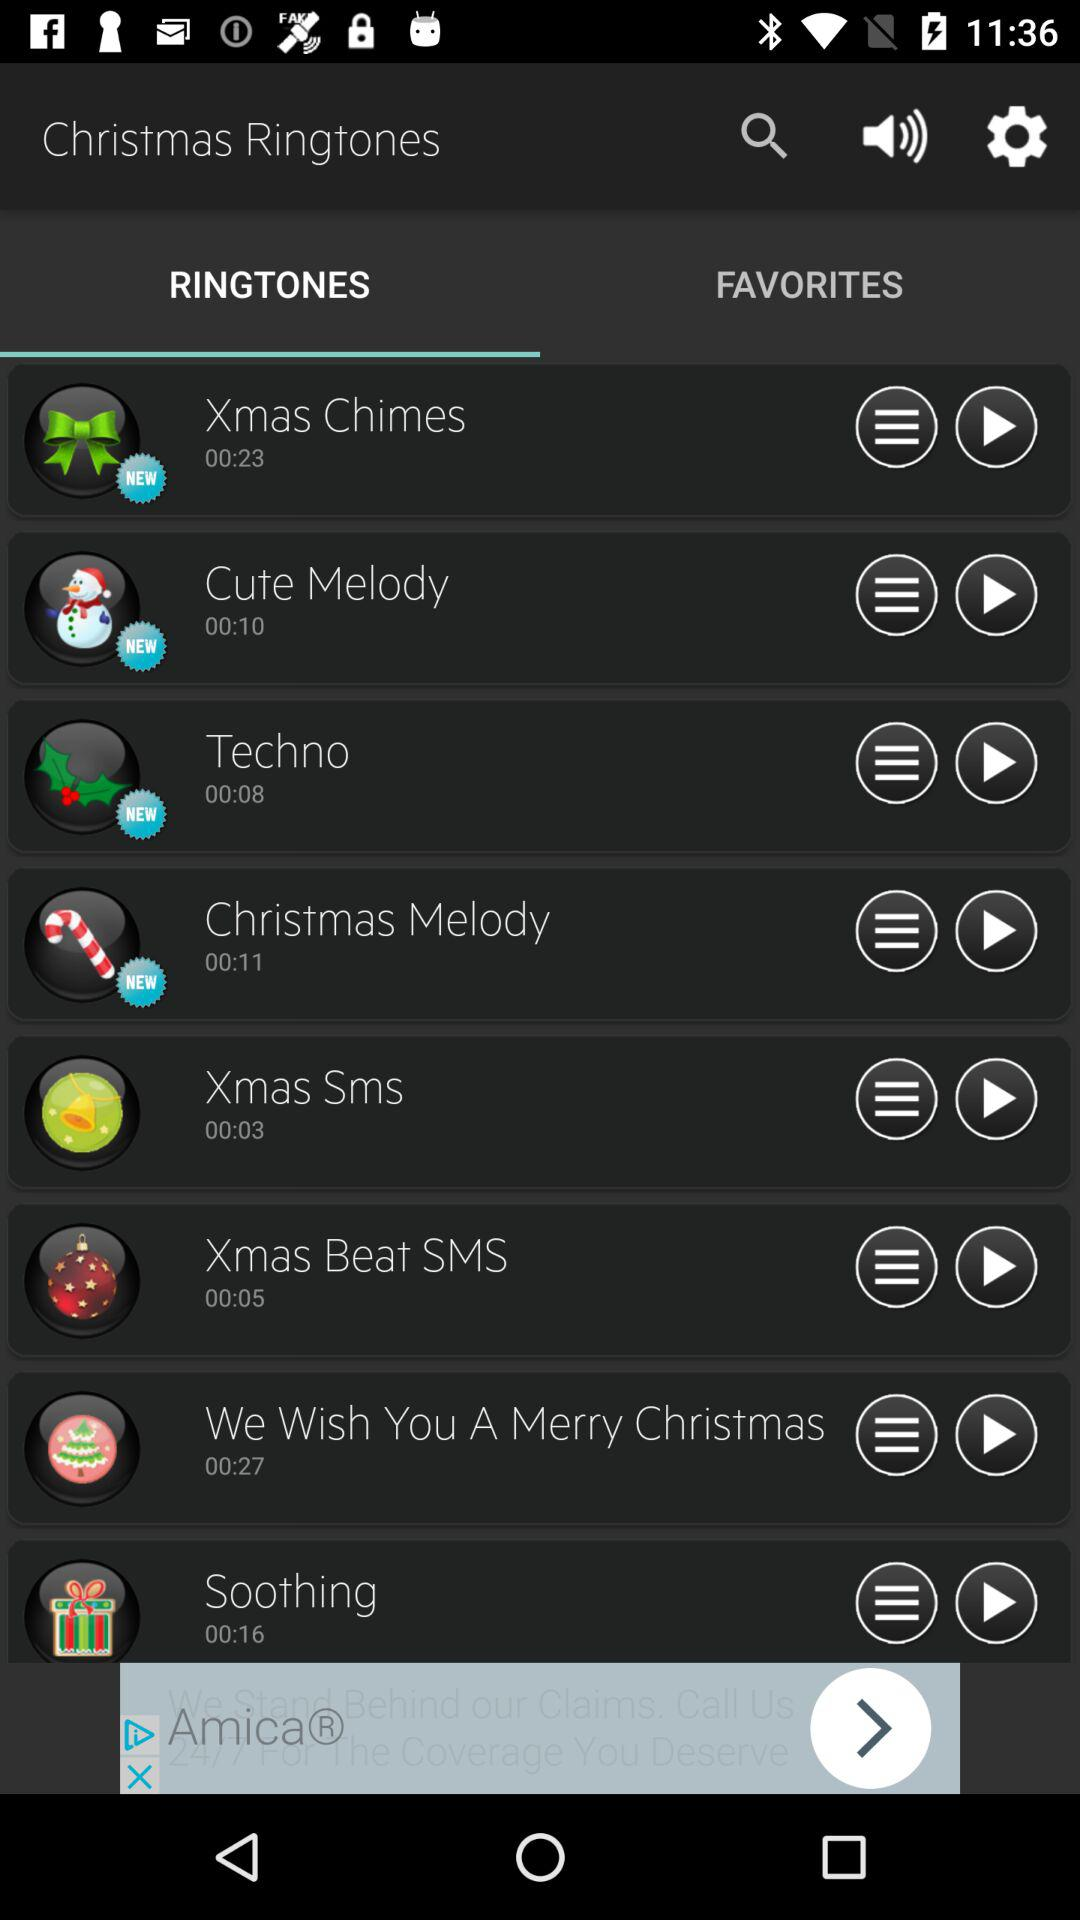How long is the duration of the "Soothing" ringtone? The duration of the "Soothing" ringtone is 16 seconds. 